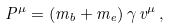Convert formula to latex. <formula><loc_0><loc_0><loc_500><loc_500>P ^ { \mu } = ( m _ { b } + m _ { e } ) \, \gamma \, v ^ { \mu } \, ,</formula> 